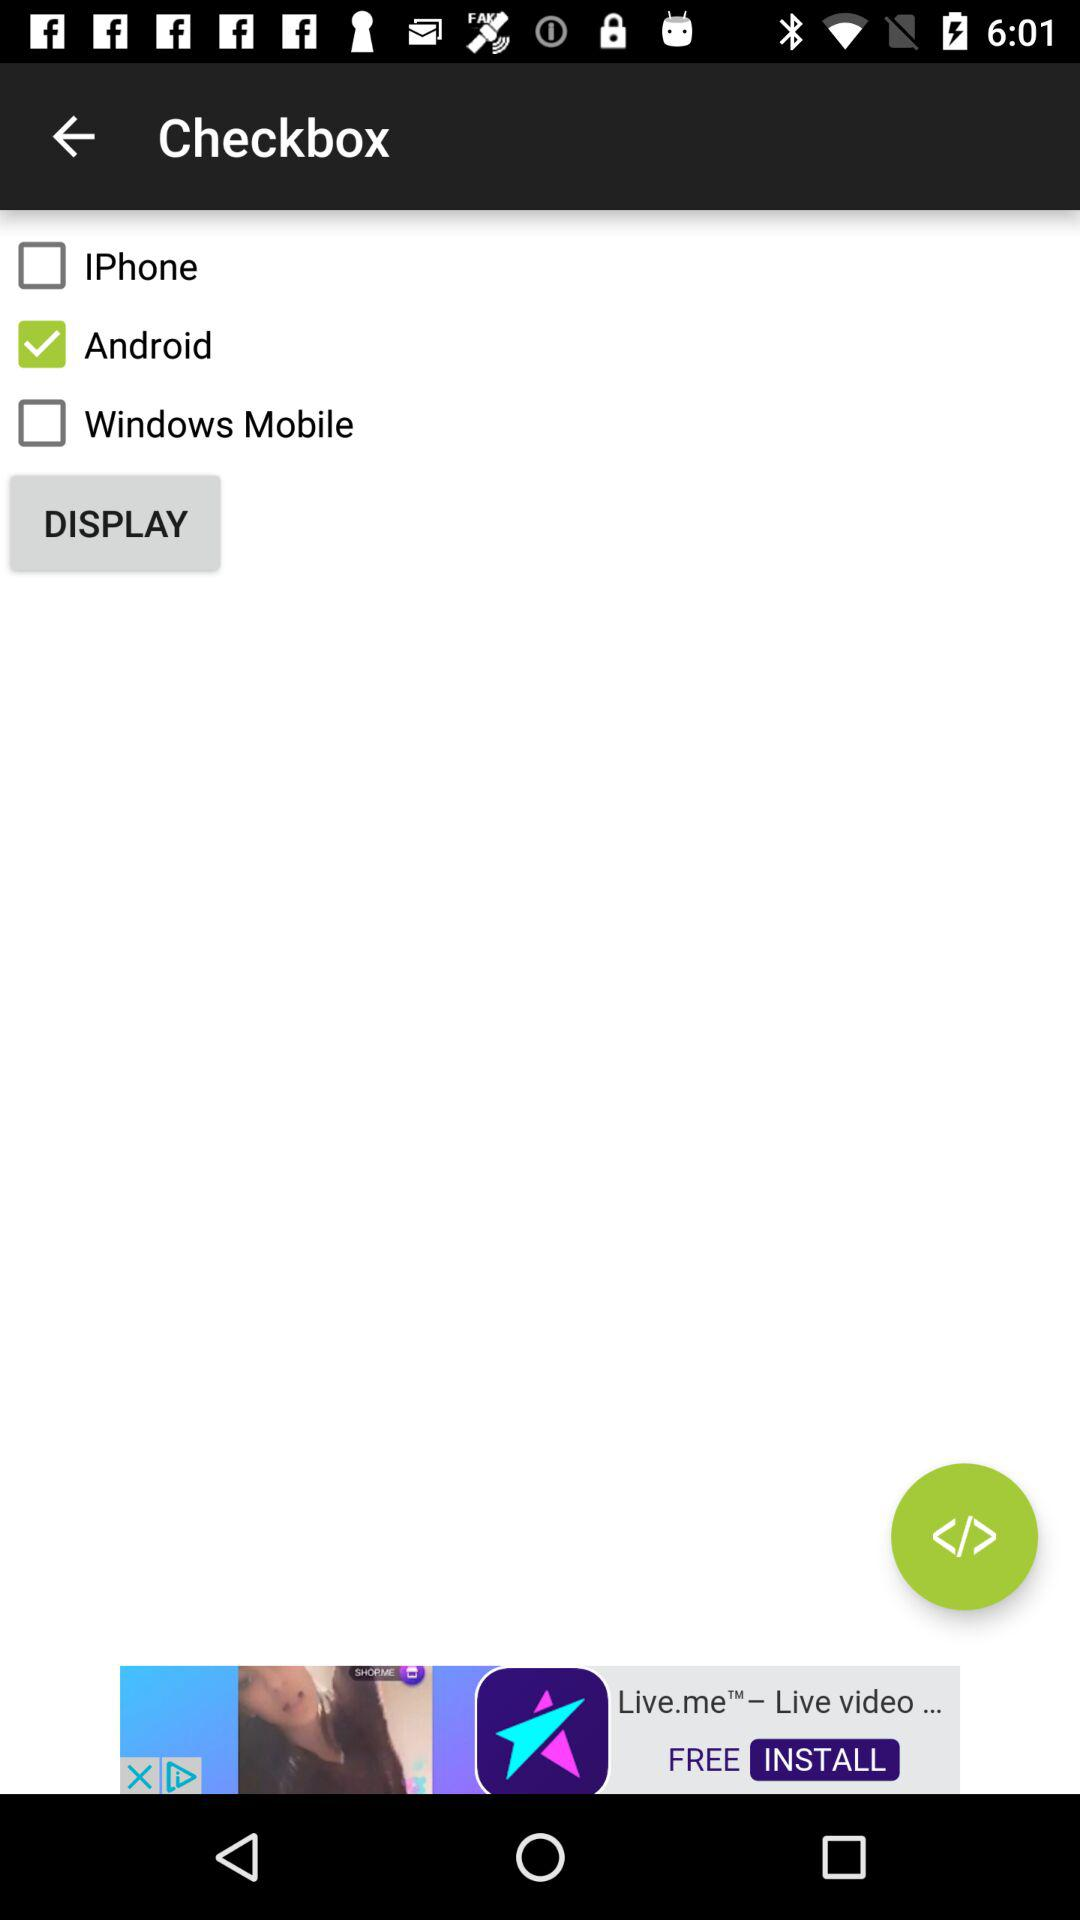Which checkbox is checked? The checked checkbox is "Android". 